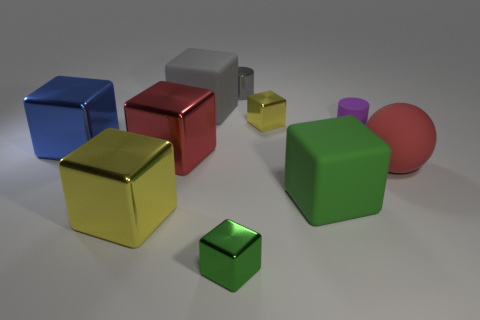Are there any other cyan balls that have the same size as the sphere?
Your response must be concise. No. What is the material of the gray cube that is the same size as the blue shiny object?
Make the answer very short. Rubber. There is a object right of the purple matte thing; is it the same size as the matte cube that is on the right side of the gray metallic cylinder?
Ensure brevity in your answer.  Yes. What number of things are either big red objects or large rubber objects that are on the right side of the big gray matte thing?
Offer a very short reply. 3. Is there a red matte object that has the same shape as the small yellow metallic object?
Your response must be concise. No. What is the size of the yellow block left of the gray thing that is left of the green metal thing?
Your response must be concise. Large. Is the color of the matte cylinder the same as the metal cylinder?
Give a very brief answer. No. What number of metallic things are either things or large gray things?
Offer a very short reply. 6. How many large yellow things are there?
Provide a short and direct response. 1. Do the small block in front of the small yellow shiny thing and the green cube to the right of the tiny gray object have the same material?
Provide a short and direct response. No. 